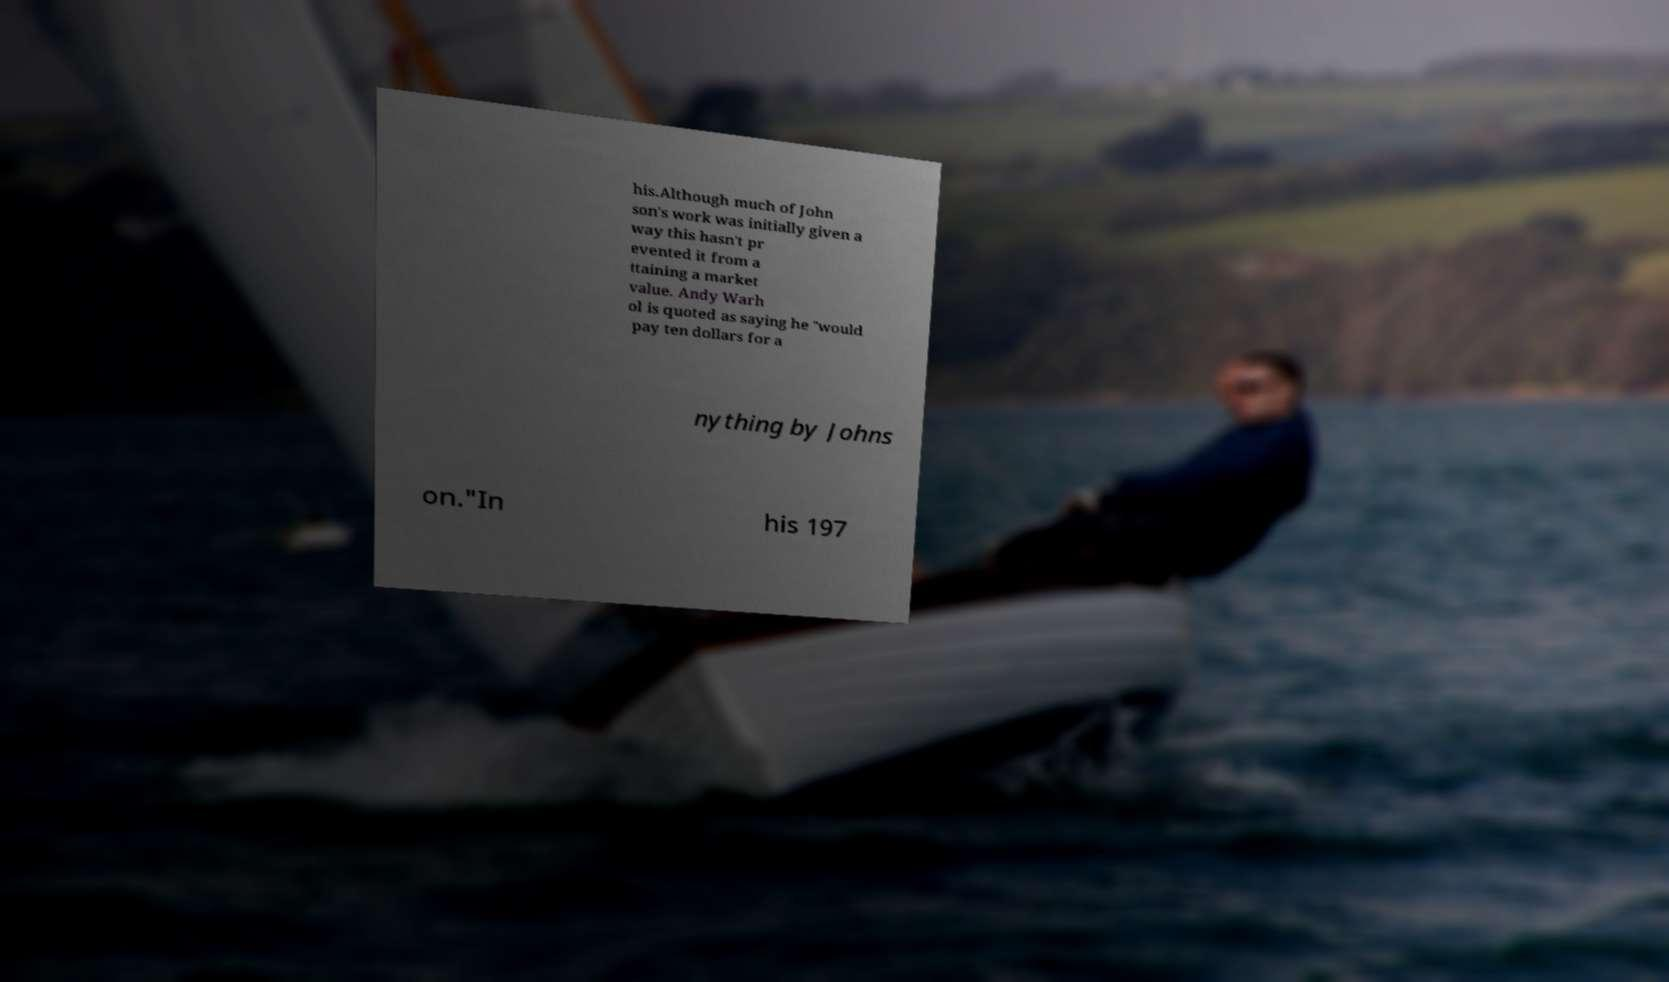Can you accurately transcribe the text from the provided image for me? his.Although much of John son's work was initially given a way this hasn't pr evented it from a ttaining a market value. Andy Warh ol is quoted as saying he "would pay ten dollars for a nything by Johns on."In his 197 